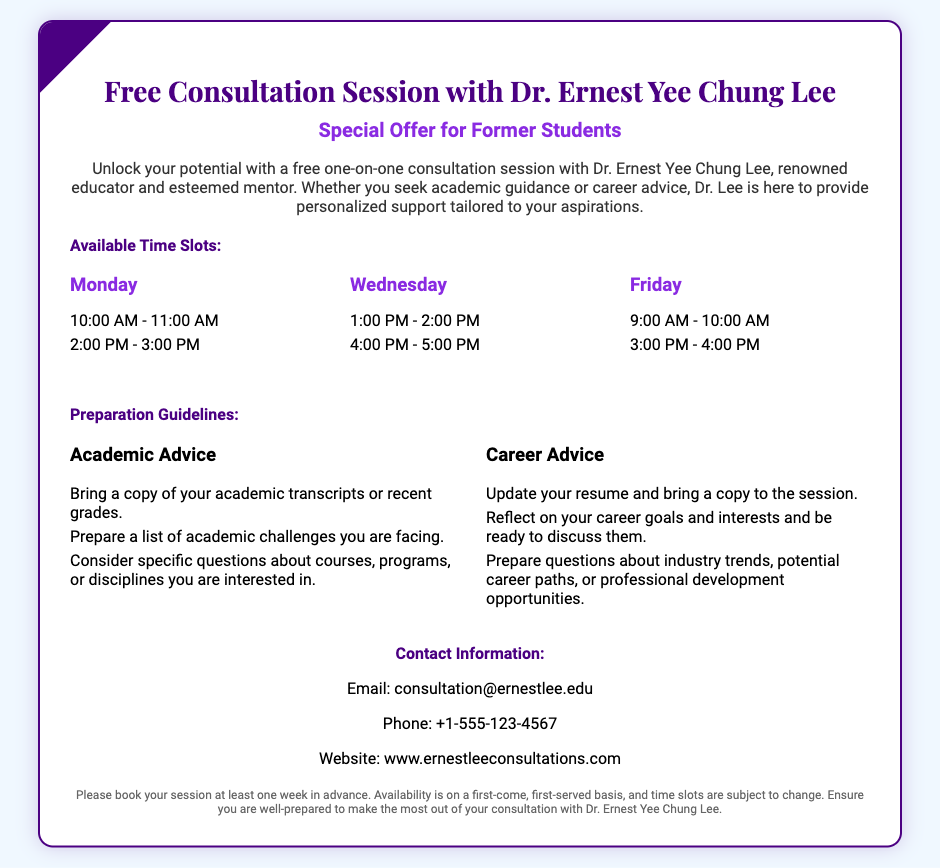What is the main purpose of the voucher? The description in the document states that the voucher is for a free one-on-one consultation session with Dr. Ernest Yee Chung Lee for academic guidance or career advice.
Answer: Free consultation session What day offers a time slot of 4:00 PM - 5:00 PM? The days and their corresponding time slots are listed in the document, and Wednesday includes this time slot.
Answer: Wednesday What should you bring for academic advice? The preparation guidelines specify that you should bring a copy of your academic transcripts or recent grades.
Answer: Academic transcripts How many time slots are available on Friday? The document details the time slots per day, showing that there are two time slots available on Friday.
Answer: 2 What contact method is provided for inquiries? The document lists an email address for contacting Dr. Ernest Yee Chung Lee for further inquiries about the consultation sessions.
Answer: consultation@ernestlee.edu What is required for booking the session? The footer notes that sessions should be booked at least one week in advance to ensure availability.
Answer: One week in advance What industry-related guidance is offered? The guidelines for career advice mention preparing questions about industry trends and potential career paths.
Answer: Industry trends How are the available time slots allocated? The document organizes time slots by day, showing a specific distribution of availability across Monday, Wednesday, and Friday.
Answer: By day 